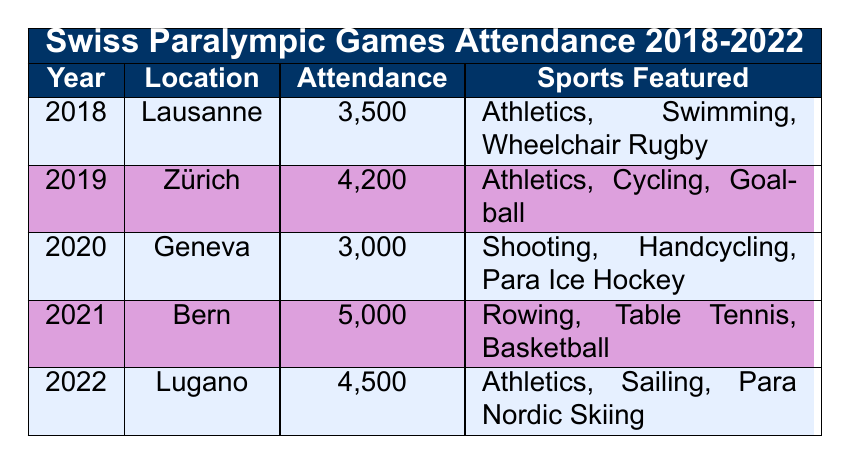What was the attendance at the 2019 Swiss Paralympic Games? According to the table, the attendance for the 2019 Swiss Paralympic Games held in Zürich was 4,200.
Answer: 4,200 In which year was the location Geneva used for the Swiss Paralympic Games? The table indicates that Geneva was the location for the Swiss Paralympic Games in the year 2020.
Answer: 2020 Which event had the highest attendance from 2018 to 2022? To determine this, we compare the attendance numbers: 3,500 (2018), 4,200 (2019), 3,000 (2020), 5,000 (2021), and 4,500 (2022). The highest attendance is 5,000 in 2021.
Answer: 5,000 How many total attendees were present across all Swiss Paralympic Games from 2018 to 2022? By summing the attendance numbers for each year: 3,500 + 4,200 + 3,000 + 5,000 + 4,500 = 20,200. Therefore, the total attendance is 20,200.
Answer: 20,200 Did the attendance increase from 2020 to 2021? The attendance in 2020 was 3,000, and in 2021 it was 5,000. Since 5,000 is greater than 3,000, we conclude there was an increase in attendance.
Answer: Yes In which year did the event feature the sport "Table Tennis"? The table shows that "Table Tennis" was featured in the 2021 Swiss Paralympic Games held in Bern.
Answer: 2021 What was the average attendance for the Swiss Paralympic Games from 2018 to 2022? To find the average, we add the attendance numbers: 3,500 + 4,200 + 3,000 + 5,000 + 4,500 = 20,200. Then, dividing by the number of years (5), we get an average of 20,200 / 5 = 4,040.
Answer: 4,040 Was there any year where the attendance was less than 4,000? Looking at the attendance numbers from the table: 3,500 (2018), 4,200 (2019), 3,000 (2020), 5,000 (2021), and 4,500 (2022), there were years 2018 and 2020 where attendance was less than 4,000.
Answer: Yes Which location had a lower attendance, Lausanne or Lugano? The attendance for Lausanne in 2018 was 3,500, whereas for Lugano in 2022 it was 4,500. Thus, Lausanne had a lower attendance compared to Lugano.
Answer: Lausanne 